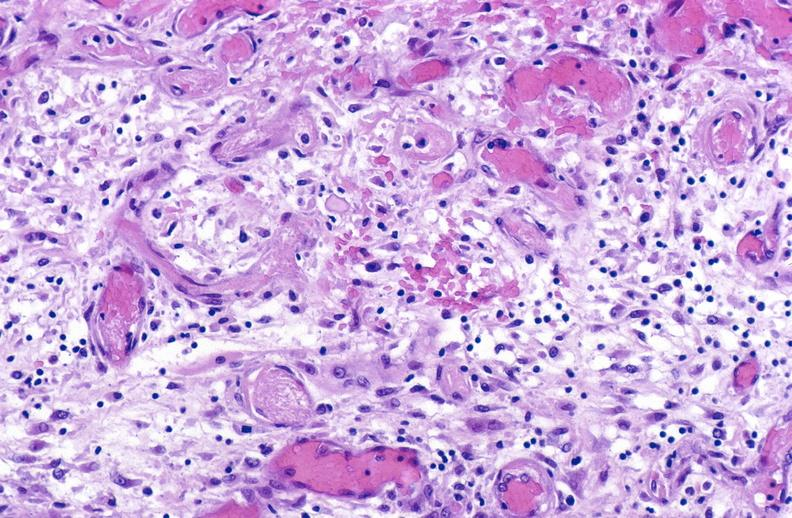s muscle present?
Answer the question using a single word or phrase. Yes 